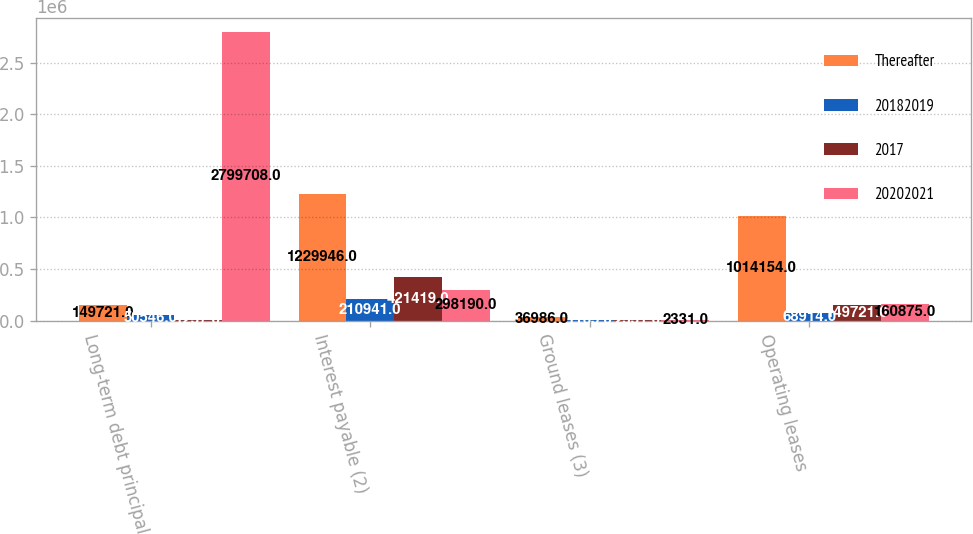Convert chart to OTSL. <chart><loc_0><loc_0><loc_500><loc_500><stacked_bar_chart><ecel><fcel>Long-term debt principal<fcel>Interest payable (2)<fcel>Ground leases (3)<fcel>Operating leases<nl><fcel>Thereafter<fcel>149721<fcel>1.22995e+06<fcel>36986<fcel>1.01415e+06<nl><fcel>20182019<fcel>50546<fcel>210941<fcel>1165<fcel>68914<nl><fcel>2017<fcel>1237<fcel>421419<fcel>2331<fcel>149721<nl><fcel>20202021<fcel>2.79971e+06<fcel>298190<fcel>2331<fcel>160875<nl></chart> 